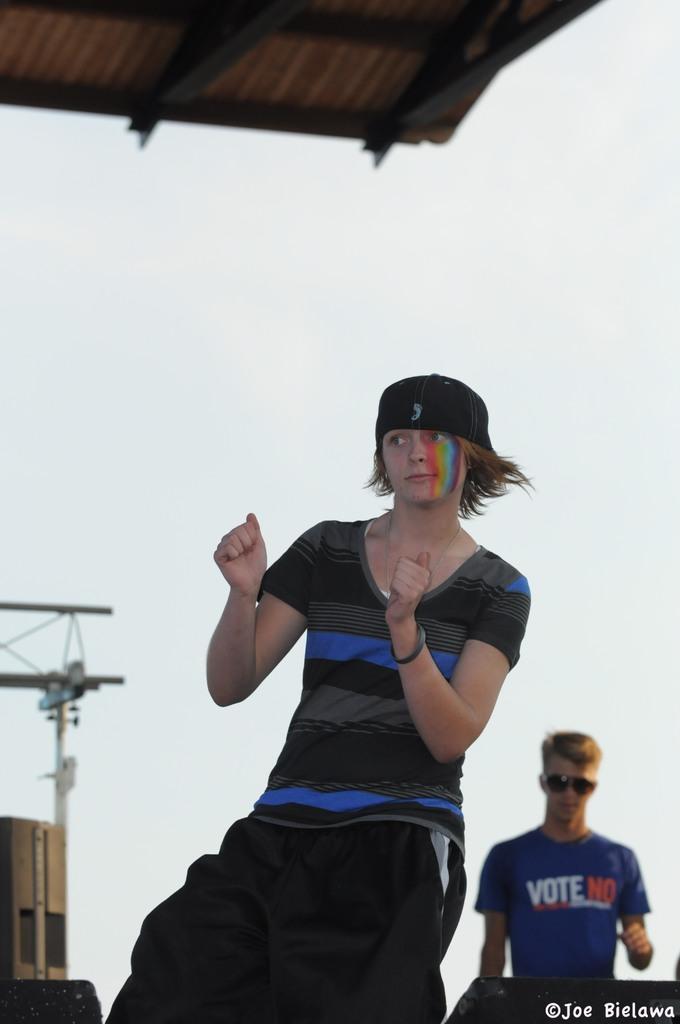Does the person in the background want you to vote yes or no?
Make the answer very short. No. Who do the person in t he background want you to vote for?
Your answer should be compact. No. 